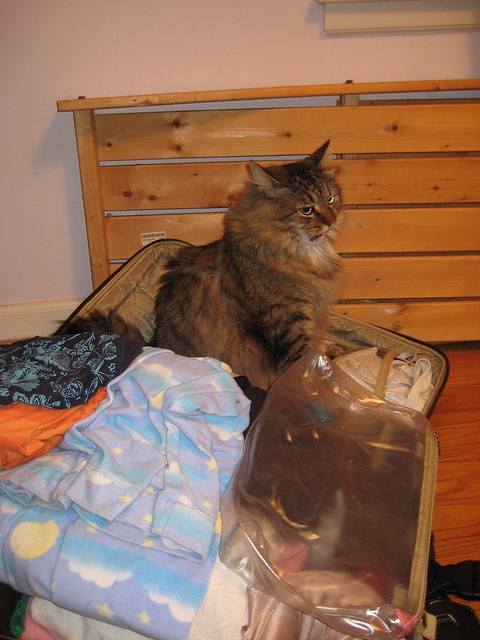Describe the objects in this image and their specific colors. I can see cat in gray, maroon, black, and brown tones and suitcase in gray, brown, and maroon tones in this image. 